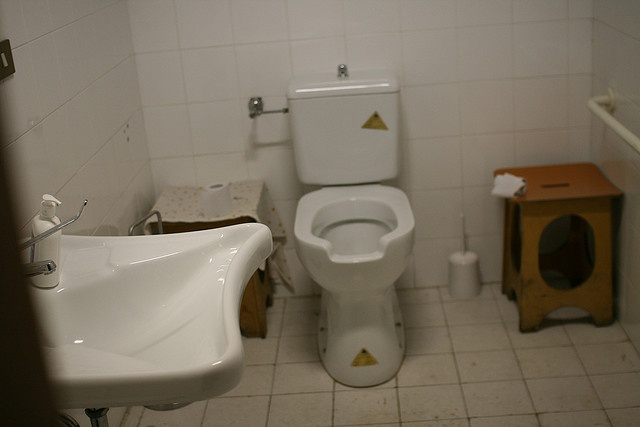Describe the objects in this image and their specific colors. I can see sink in gray, darkgray, and black tones, toilet in gray and darkgray tones, and bottle in gray and darkgray tones in this image. 